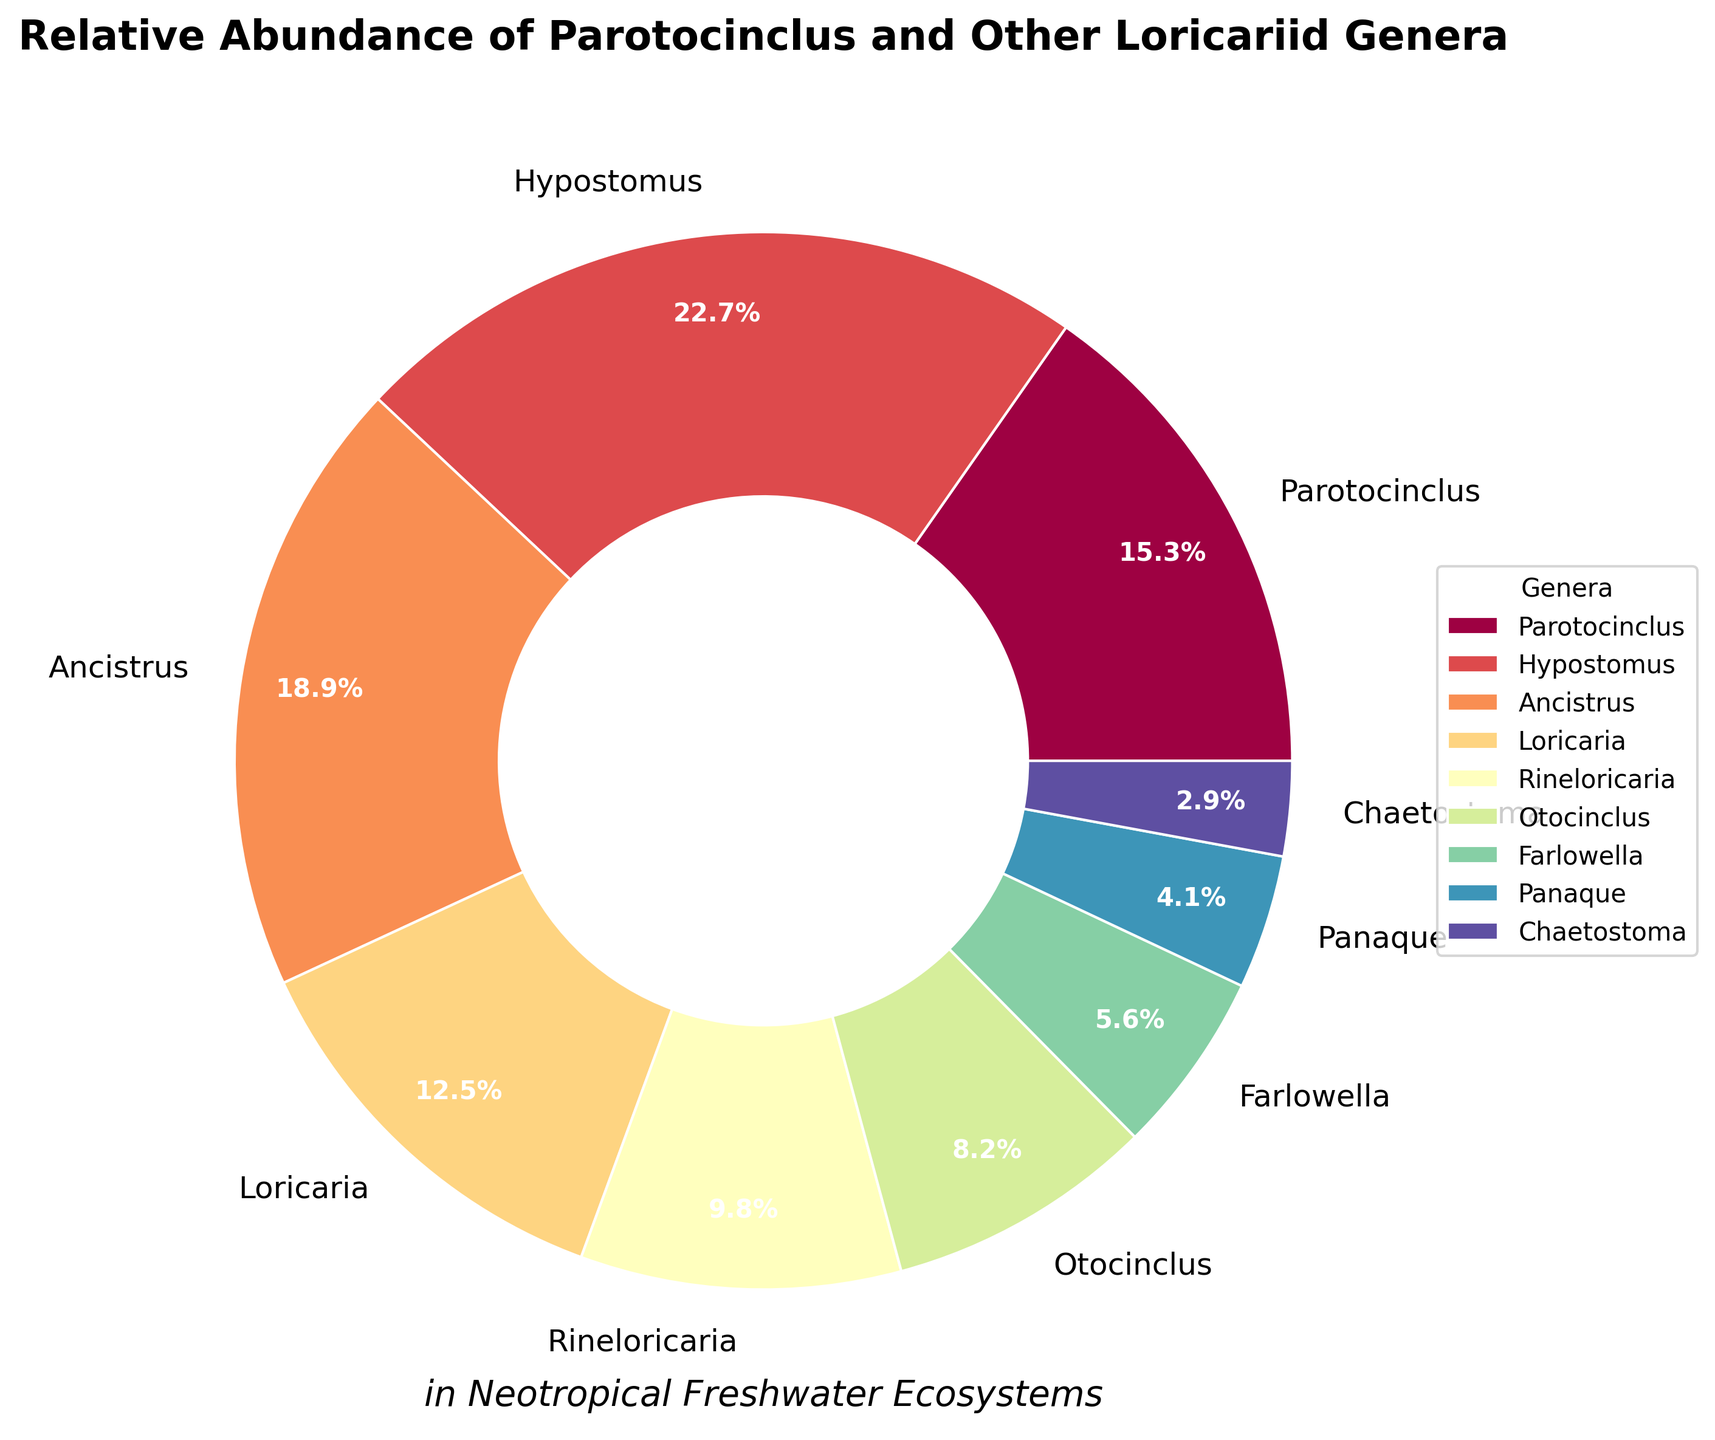What is the relative abundance of Parotocinclus compared to Otocinclus? The relative abundance of Parotocinclus is 15.3% and Otocinclus is 8.2%. To compare them, we subtract Otocinclus from Parotocinclus: 15.3 - 8.2 = 7.1%.
Answer: 7.1% Which genus has the highest relative abundance, and by how much does it exceed Parotocinclus? Hypostomus has the highest relative abundance at 22.7%. To find the difference between Hypostomus and Parotocinclus, we subtract the two values: 22.7 - 15.3 = 7.4%.
Answer: Hypostomus, 7.4% What is the combined relative abundance of Ancistrus, Rineloricaria, and Otocinclus? To find the combined relative abundance, we sum the values for Ancistrus (18.9%), Rineloricaria (9.8%), and Otocinclus (8.2%): 18.9 + 9.8 + 8.2 = 36.9%.
Answer: 36.9% How does the relative abundance of Loricaria compare to Farlowella? Loricaria has a relative abundance of 12.5%, and Farlowella has 5.6%. Subtract Farlowella from Loricaria: 12.5 - 5.6 = 6.9%.
Answer: Loricaria exceeds by 6.9% What is the average relative abundance of all genera excluding Parotocinclus? Exclude Parotocinclus and sum the abundances of the other genera: 22.7 + 18.9 + 12.5 + 9.8 + 8.2 + 5.6 + 4.1 + 2.9 = 84.7. Then, divide by the number of remaining genera (8): 84.7 / 8 = 10.59%.
Answer: 10.59% Which genera combined make up more than 50% of the total relative abundance? Sum the abundances in descending order until the sum exceeds 50%: Hypostomus (22.7%) + Ancistrus (18.9%) + Parotocinclus (15.3%) = 56.9%. Therefore, Hypostomus, Ancistrus, and Parotocinclus combined exceed 50%.
Answer: Hypostomus, Ancistrus, and Parotocinclus Which genus has the smallest relative abundance, and what percentage is it? The genus with the smallest relative abundance is Chaetostoma at 2.9%.
Answer: Chaetostoma, 2.9% What visual color is associated with the genus Panaque in the chart? The custom color palette follows the order of genera. Since Panaque is the eighth genus in the list, it corresponds to the eighth color in the 'Spectral' color map, typically a shade of blue or violet.
Answer: Blue/violet How does the combined relative abundance of the genera Farlowella, Panaque, and Chaetostoma compare to Parotocinclus? Sum the abundances of Farlowella (5.6%), Panaque (4.1%), and Chaetostoma (2.9%): 5.6 + 4.1 + 2.9 = 12.6%. Then, subtract this from Parotocinclus (15.3%): 15.3 - 12.6 = 2.7%.
Answer: Parotocinclus exceeds by 2.7% What percentage of the total relative abundance is made up by genera with less than 10% each? Identifying genera with less than 10%: Rineloricaria (9.8%), Otocinclus (8.2%), Farlowella (5.6%), Panaque (4.1%), and Chaetostoma (2.9%). Sum these percentages: 9.8 + 8.2 + 5.6 + 4.1 + 2.9 = 30.6%.
Answer: 30.6% 